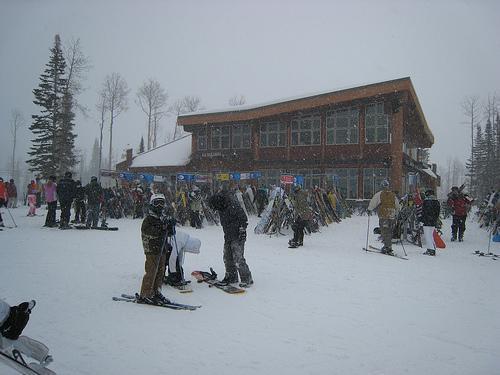How many buildings?
Give a very brief answer. 1. 